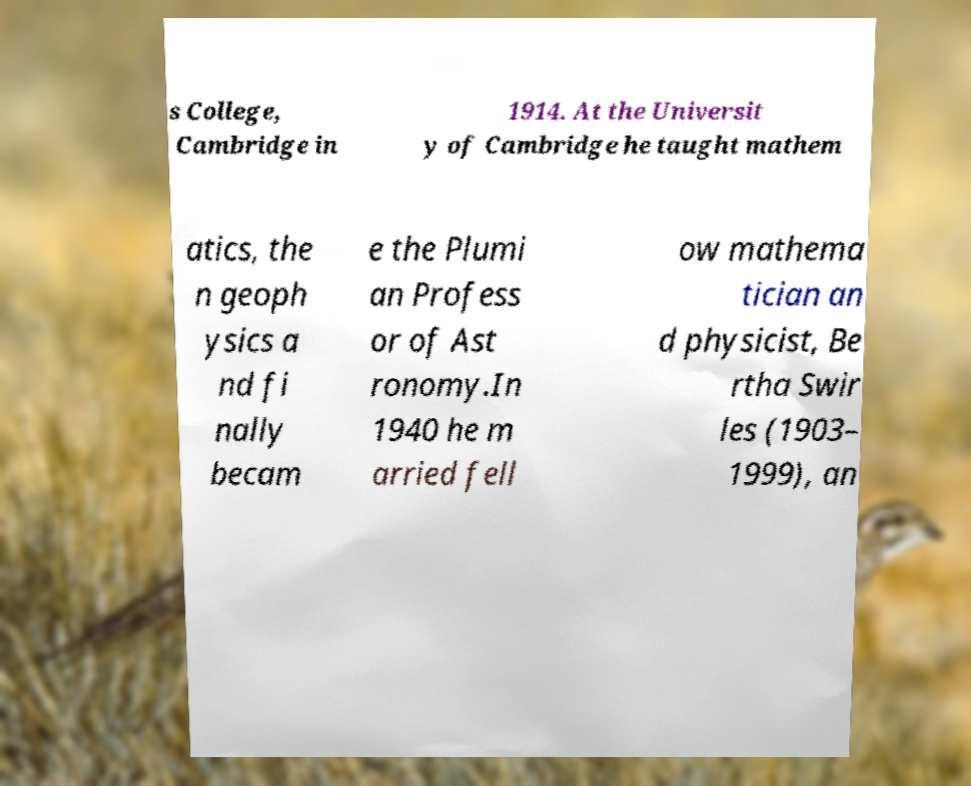Please read and relay the text visible in this image. What does it say? s College, Cambridge in 1914. At the Universit y of Cambridge he taught mathem atics, the n geoph ysics a nd fi nally becam e the Plumi an Profess or of Ast ronomy.In 1940 he m arried fell ow mathema tician an d physicist, Be rtha Swir les (1903– 1999), an 